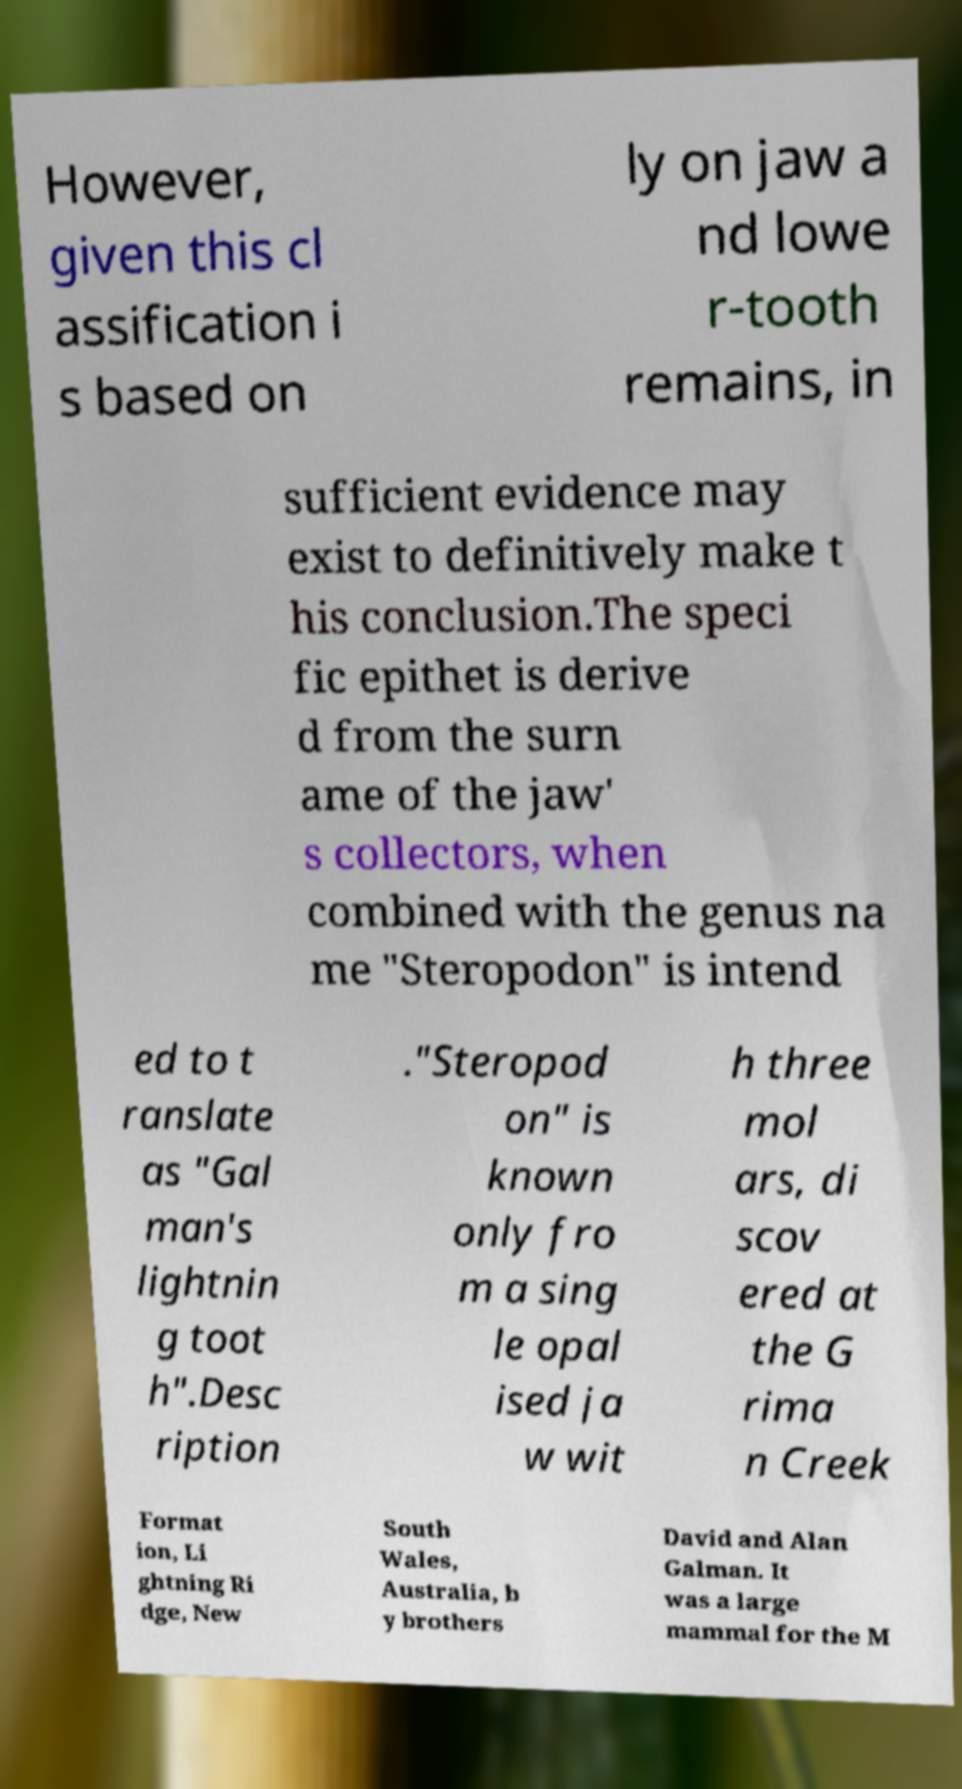There's text embedded in this image that I need extracted. Can you transcribe it verbatim? However, given this cl assification i s based on ly on jaw a nd lowe r-tooth remains, in sufficient evidence may exist to definitively make t his conclusion.The speci fic epithet is derive d from the surn ame of the jaw' s collectors, when combined with the genus na me "Steropodon" is intend ed to t ranslate as "Gal man's lightnin g toot h".Desc ription ."Steropod on" is known only fro m a sing le opal ised ja w wit h three mol ars, di scov ered at the G rima n Creek Format ion, Li ghtning Ri dge, New South Wales, Australia, b y brothers David and Alan Galman. It was a large mammal for the M 